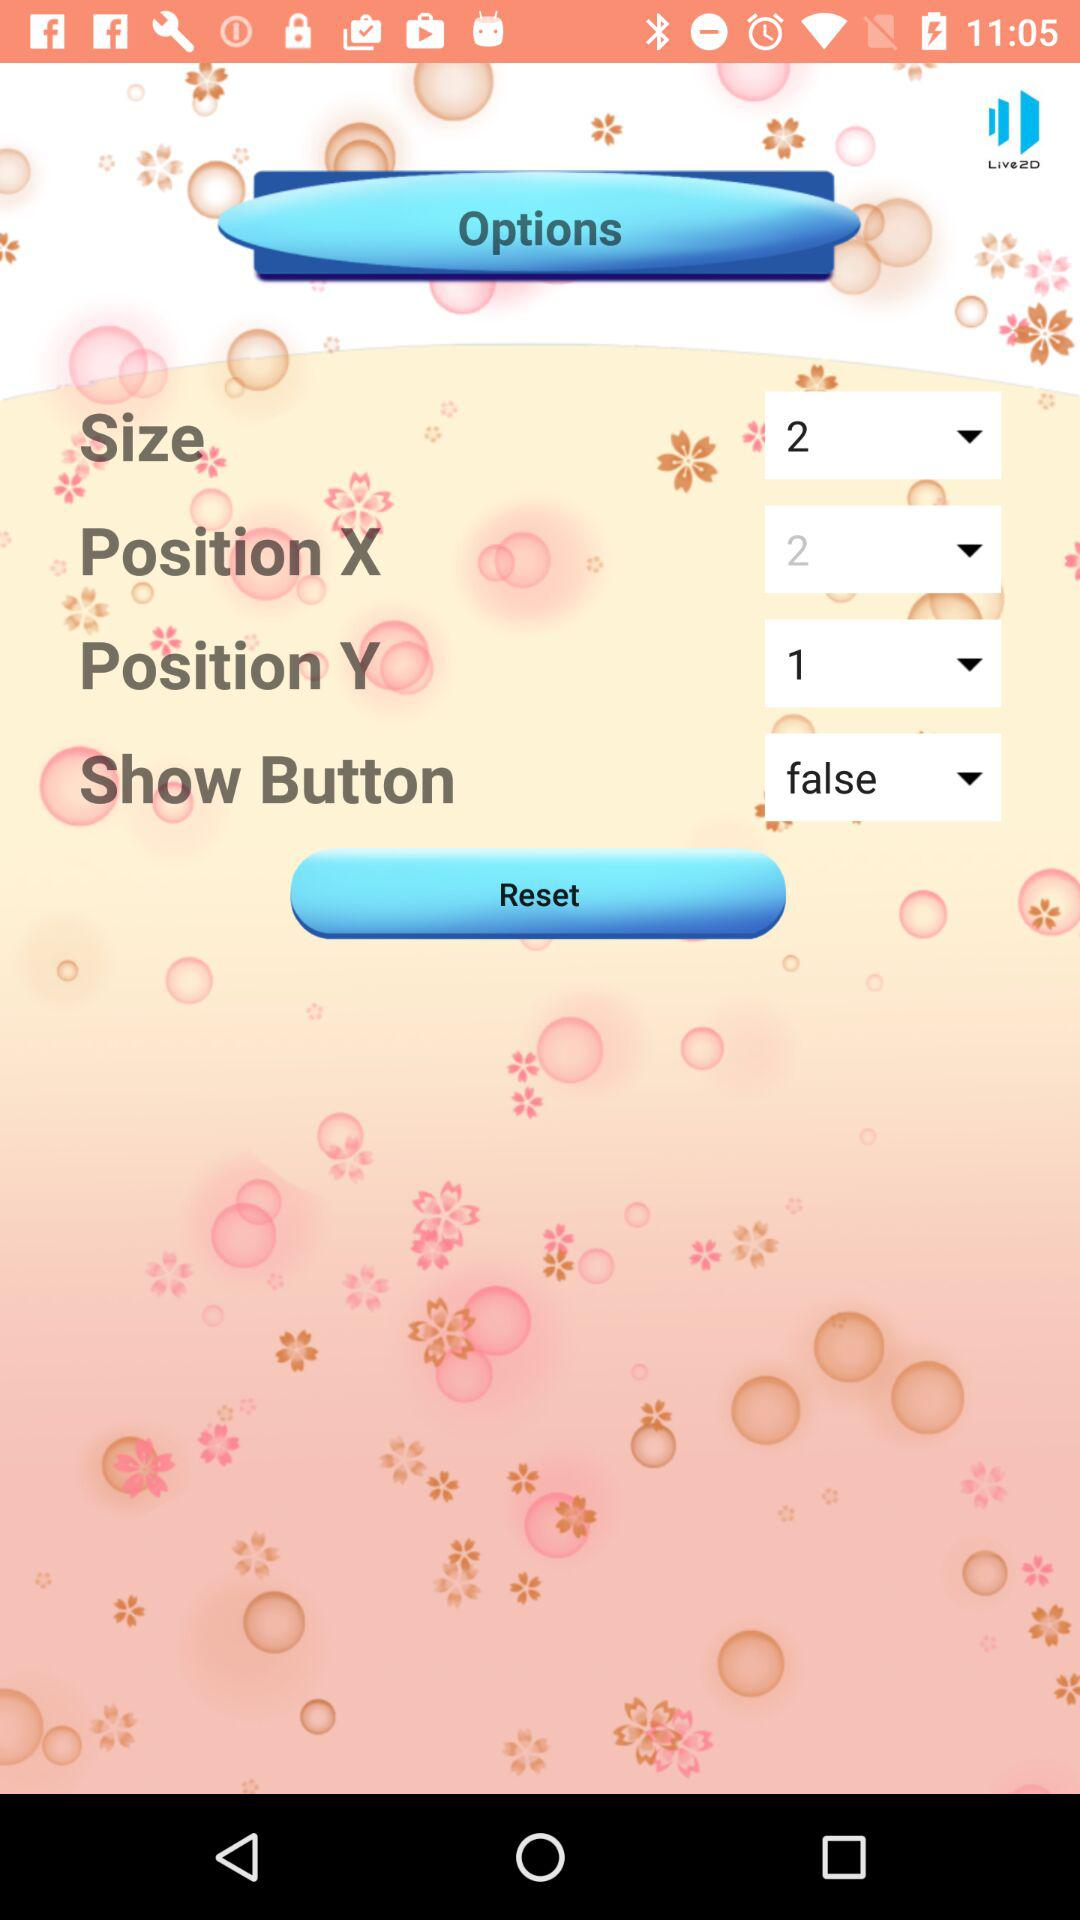Which size is selected? The selected size is 2. 